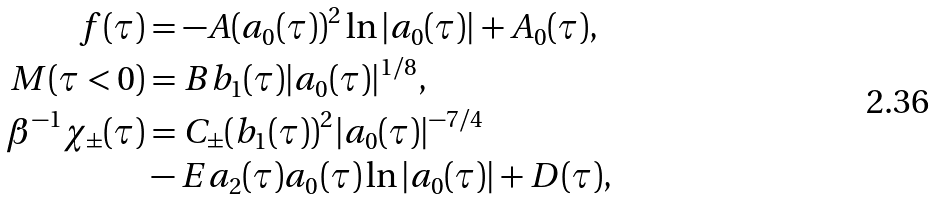Convert formula to latex. <formula><loc_0><loc_0><loc_500><loc_500>f ( \tau ) & = - A ( a _ { 0 } ( \tau ) ) ^ { 2 } \ln { | a _ { 0 } ( \tau ) | } + A _ { 0 } ( \tau ) , \\ M ( \tau < 0 ) & = B b _ { 1 } ( \tau ) | a _ { 0 } ( \tau ) | ^ { 1 / 8 } , \\ \beta ^ { - 1 } \chi _ { \pm } ( \tau ) & = C _ { \pm } ( b _ { 1 } ( \tau ) ) ^ { 2 } | a _ { 0 } ( \tau ) | ^ { - 7 / 4 } \\ & - E a _ { 2 } ( \tau ) a _ { 0 } ( \tau ) \ln { | a _ { 0 } ( \tau ) | } + D ( \tau ) ,</formula> 